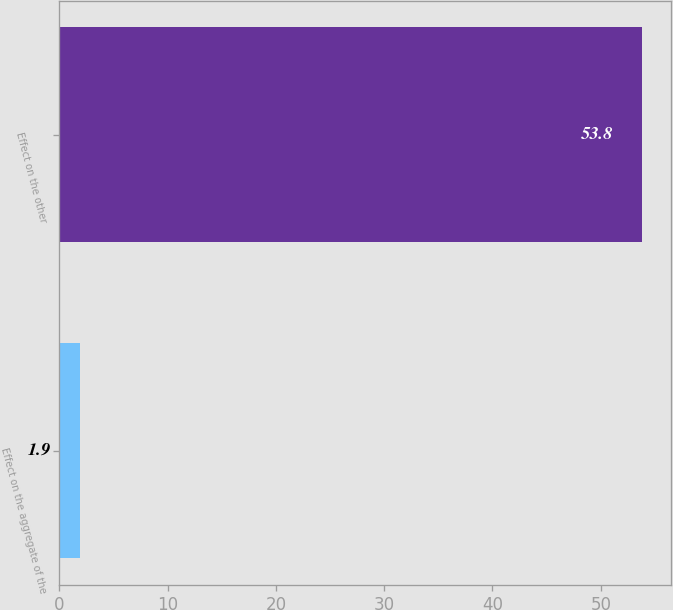<chart> <loc_0><loc_0><loc_500><loc_500><bar_chart><fcel>Effect on the aggregate of the<fcel>Effect on the other<nl><fcel>1.9<fcel>53.8<nl></chart> 